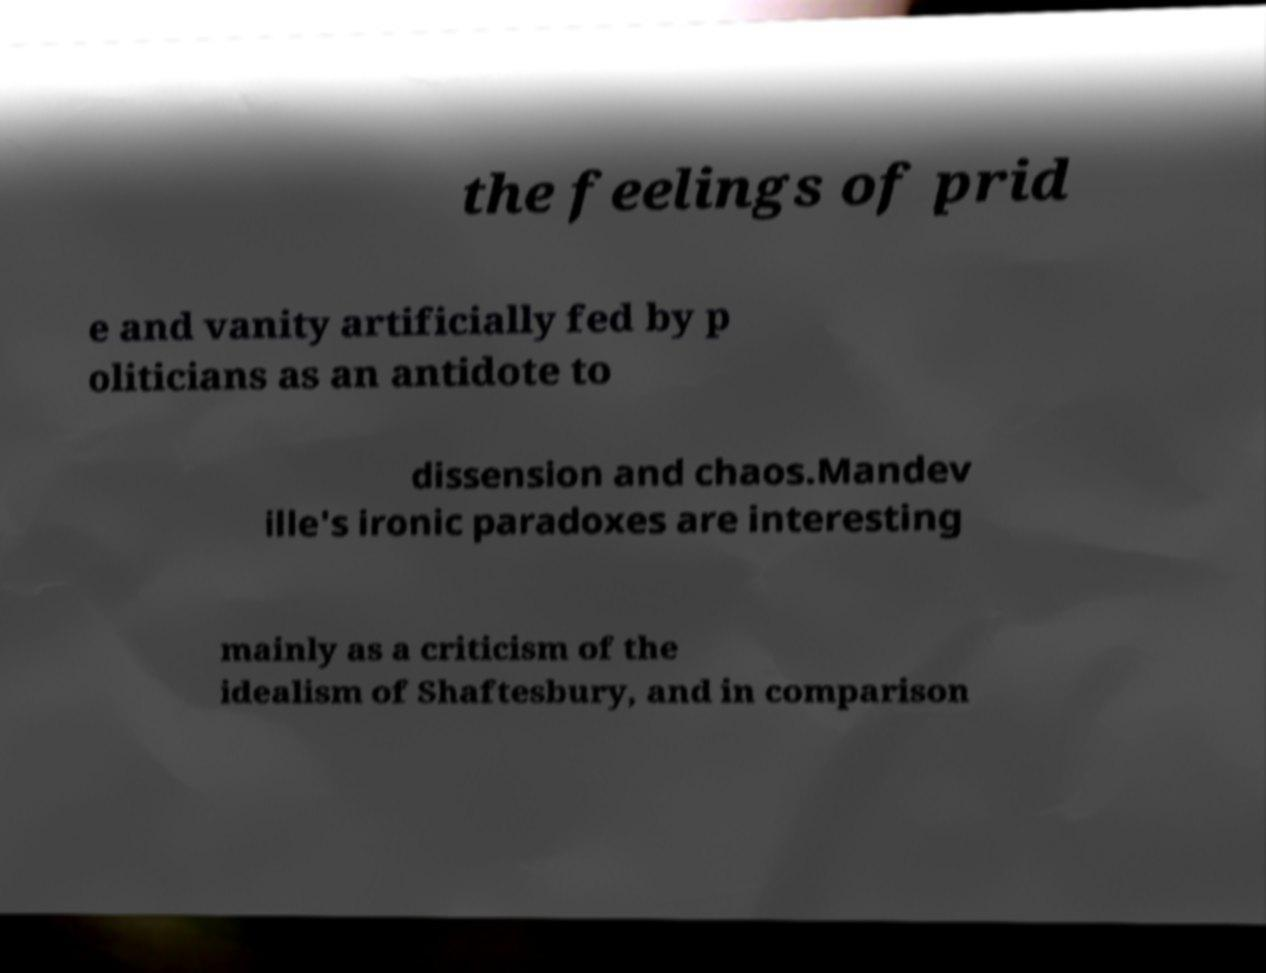Please identify and transcribe the text found in this image. the feelings of prid e and vanity artificially fed by p oliticians as an antidote to dissension and chaos.Mandev ille's ironic paradoxes are interesting mainly as a criticism of the idealism of Shaftesbury, and in comparison 